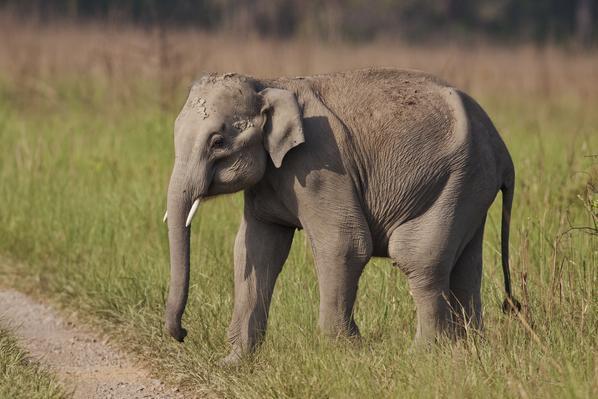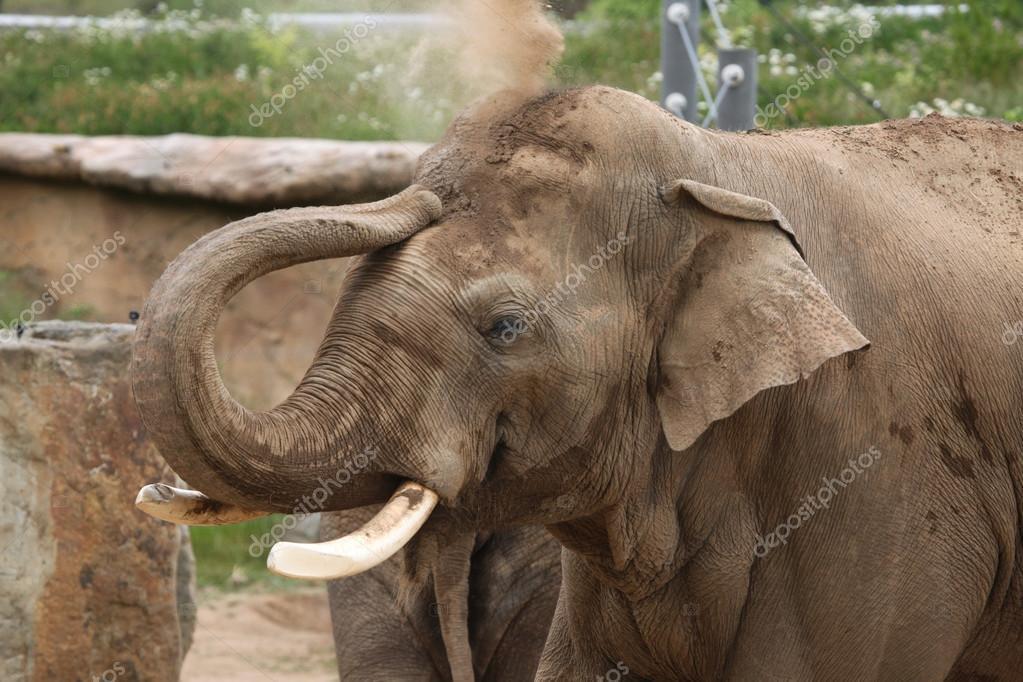The first image is the image on the left, the second image is the image on the right. Analyze the images presented: Is the assertion "The right image contains exactly one elephant that is walking towards the right." valid? Answer yes or no. No. The first image is the image on the left, the second image is the image on the right. Given the left and right images, does the statement "Both elephants have white tusks." hold true? Answer yes or no. Yes. 